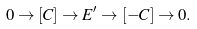<formula> <loc_0><loc_0><loc_500><loc_500>0 \rightarrow [ C ] \rightarrow E ^ { \prime } \rightarrow [ - C ] \rightarrow 0 .</formula> 